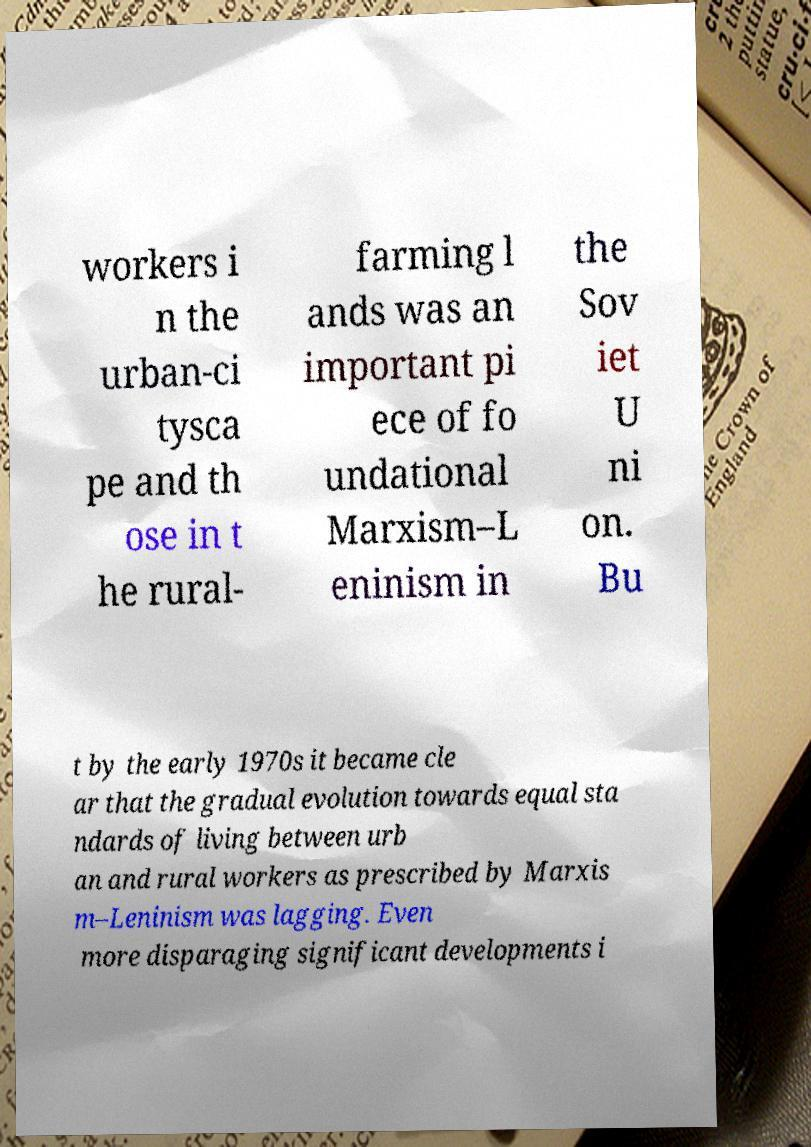Can you read and provide the text displayed in the image?This photo seems to have some interesting text. Can you extract and type it out for me? workers i n the urban-ci tysca pe and th ose in t he rural- farming l ands was an important pi ece of fo undational Marxism–L eninism in the Sov iet U ni on. Bu t by the early 1970s it became cle ar that the gradual evolution towards equal sta ndards of living between urb an and rural workers as prescribed by Marxis m–Leninism was lagging. Even more disparaging significant developments i 